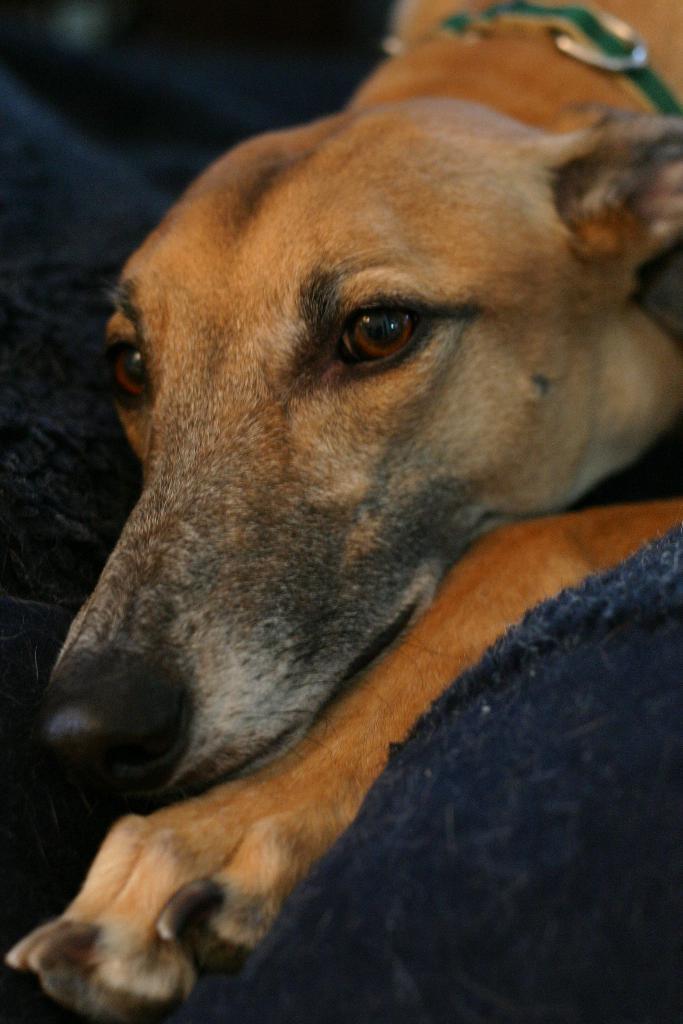Describe this image in one or two sentences. In this image I can see a blue colour cloth and on it I can see a cream colour dog. 